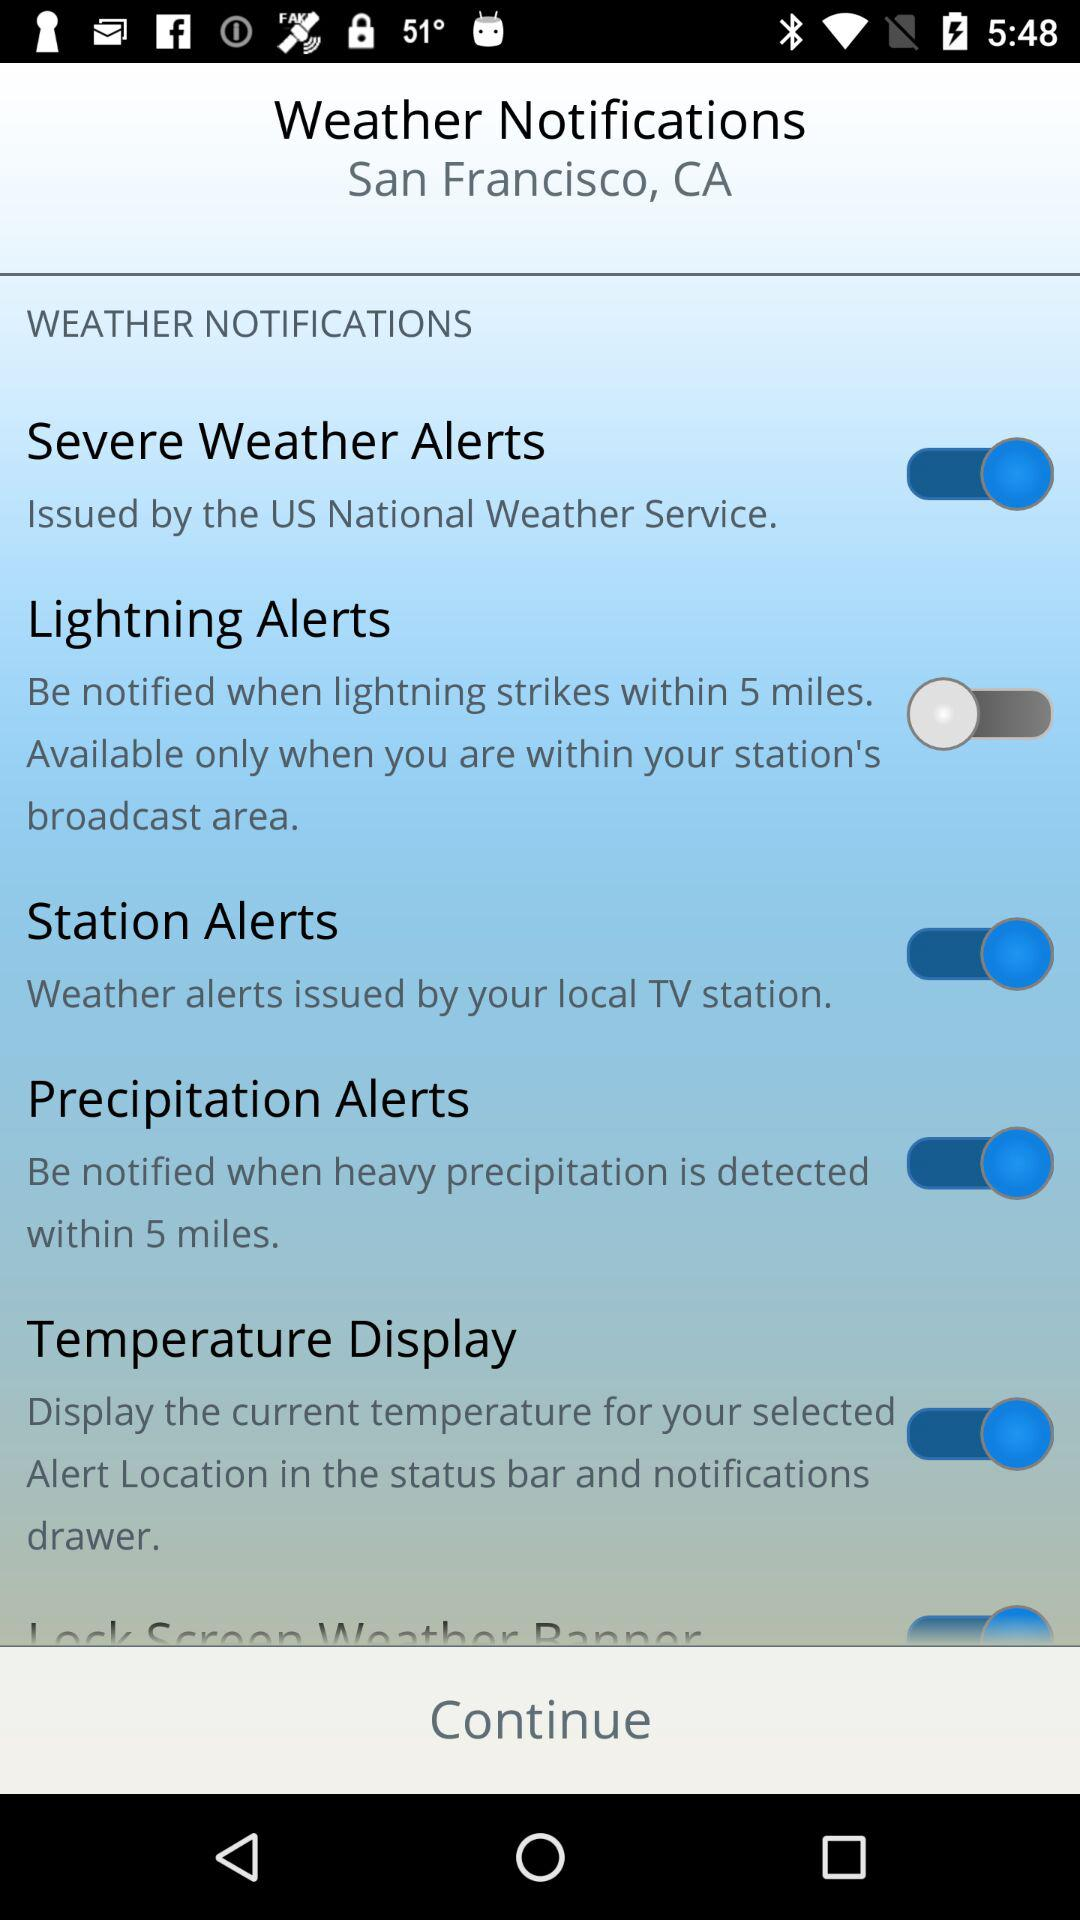How many types of alerts are available?
Answer the question using a single word or phrase. 5 